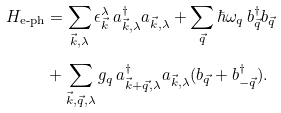Convert formula to latex. <formula><loc_0><loc_0><loc_500><loc_500>H _ { \text {e-ph} } & = \sum _ { \vec { k } , \lambda } \epsilon ^ { \lambda } _ { \vec { k } } \, a ^ { \dagger } _ { \vec { k } , \lambda } a _ { \vec { k } , \lambda } + \sum _ { \vec { q } } \hbar { \omega } _ { q } \, b ^ { \dagger } _ { \vec { q } } b _ { \vec { q } } \\ & + \sum _ { \vec { k } , \vec { q } , \lambda } g _ { q } \, a ^ { \dagger } _ { \vec { k } + \vec { q } , \lambda } a _ { \vec { k } , \lambda } ( b _ { \vec { q } } + b ^ { \dagger } _ { - \vec { q } } ) .</formula> 